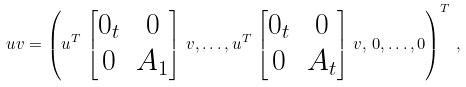Convert formula to latex. <formula><loc_0><loc_0><loc_500><loc_500>u v = \left ( u ^ { T } \, \begin{bmatrix} 0 _ { t } & 0 \\ 0 & A _ { 1 } \end{bmatrix} \, v , \dots , u ^ { T } \, \begin{bmatrix} 0 _ { t } & 0 \\ 0 & A _ { t } \end{bmatrix} \, v , \, 0 , \dots , 0 \right ) ^ { T } \, ,</formula> 